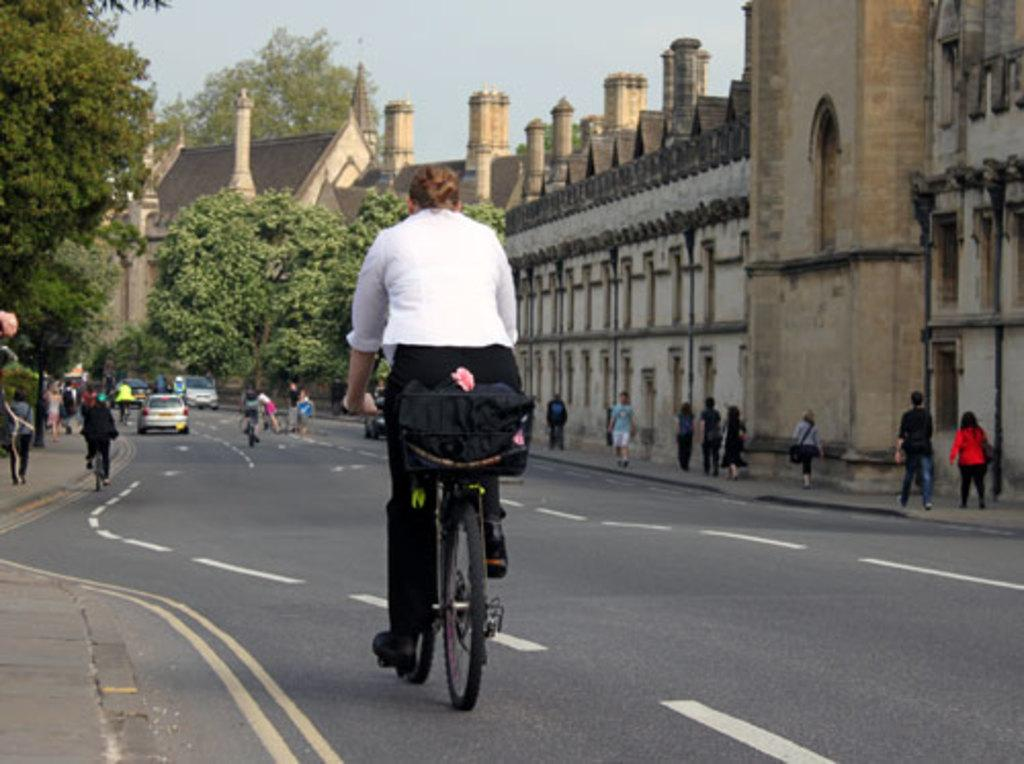Who or what can be seen in the image? There are people in the image. What else is present in the image besides people? There are trees, windows, and people riding bicycles in the image. What is visible at the top of the image? The sky is visible at the top of the image. How many ladybugs can be seen on the windows in the image? There are no ladybugs present on the windows in the image. What emotion do the people in the image feel about their past decisions? The image does not provide information about the emotions or thoughts of the people, so we cannot determine if they feel regret or any other emotion. 